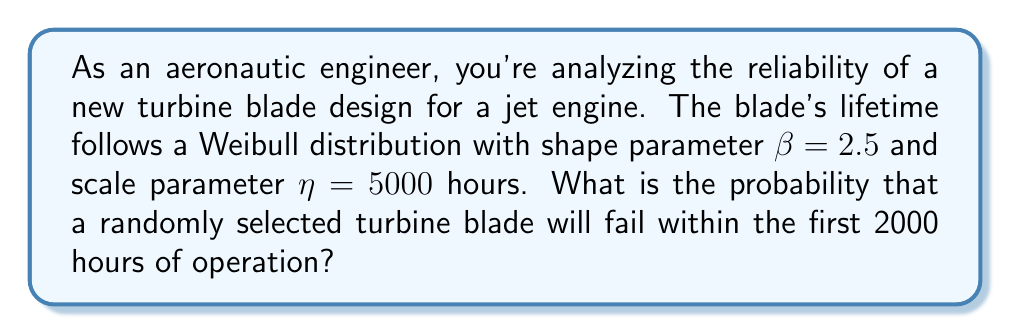Can you solve this math problem? To solve this problem, we'll use the Weibull distribution cumulative distribution function (CDF):

1) The Weibull CDF is given by:

   $$F(t) = 1 - e^{-(\frac{t}{\eta})^\beta}$$

   where $t$ is the time, $\eta$ is the scale parameter, and $\beta$ is the shape parameter.

2) We're given:
   $\beta = 2.5$
   $\eta = 5000$ hours
   $t = 2000$ hours

3) Let's substitute these values into the CDF equation:

   $$F(2000) = 1 - e^{-(\frac{2000}{5000})^{2.5}}$$

4) Simplify the fraction inside the parentheses:

   $$F(2000) = 1 - e^{-(0.4)^{2.5}}$$

5) Calculate the exponent:

   $$F(2000) = 1 - e^{-0.101}$$

6) Calculate the exponential:

   $$F(2000) = 1 - 0.904$$

7) Subtract:

   $$F(2000) = 0.096$$

Therefore, the probability that a randomly selected turbine blade will fail within the first 2000 hours of operation is approximately 0.096 or 9.6%.
Answer: 0.096 